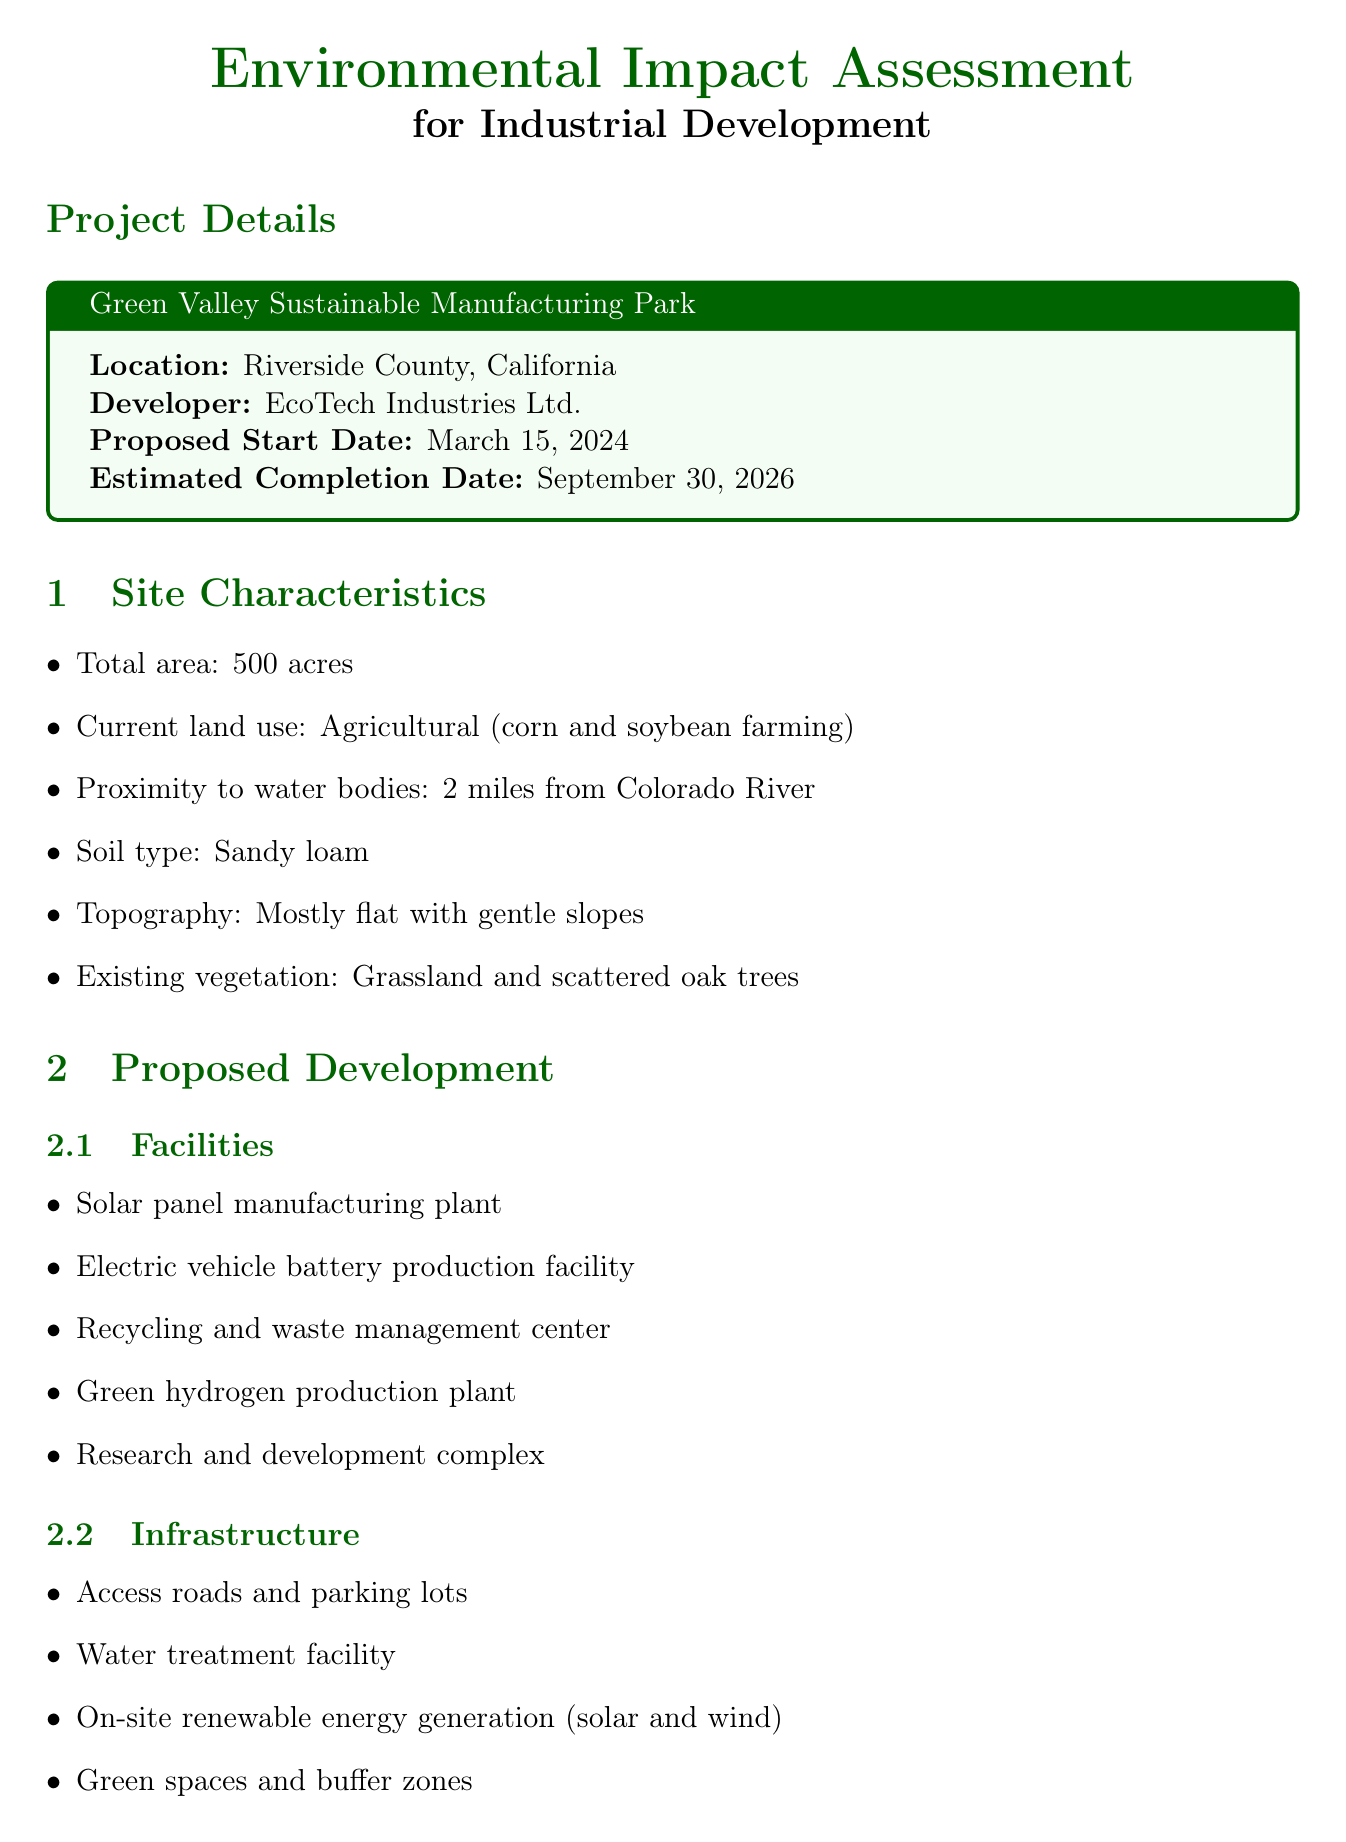What is the project name? The project name is mentioned prominently in the document's heading, specifying the development's focus.
Answer: Green Valley Sustainable Manufacturing Park What is the developer's name? The developer's name is listed in the project details section of the document.
Answer: EcoTech Industries Ltd What is the total area of the site? The document explicitly states the size of the project site in acres, providing the exact figure.
Answer: 500 acres When is the proposed start date? The proposed start date is provided in the project details section, indicating when the project intends to begin.
Answer: March 15, 2024 What type of vegetation exists on the site? The document describes the existing vegetation to give context about the ecological features of the site.
Answer: Grassland and scattered oak trees What are two potential impacts on air quality? This question aggregates information from the environmental factors section, specifically addressing air quality impacts outlined.
Answer: Emissions from manufacturing processes, Dust generation during construction What mitigation measure is proposed for noise and vibration? The document lists specific mitigation measures to address noise and vibration concerns during project implementation.
Answer: Use of noise barriers and sound-absorbing materials How many direct and indirect jobs are estimated to be created? The socio-economic impacts section of the document quantifies the job creation estimates attributable to the development.
Answer: 5,000 What is the comment period duration? The document provides specific dates outlining when public comments can be submitted during the consultation phase.
Answer: September 16, 2023 to October 16, 2023 